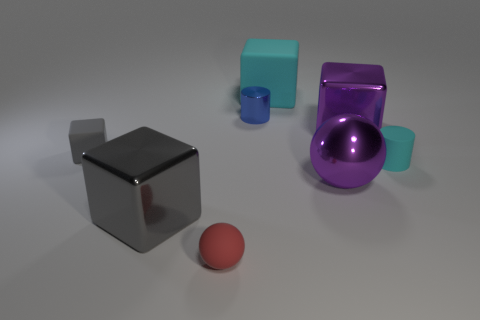Add 1 tiny blue things. How many objects exist? 9 Subtract all cylinders. How many objects are left? 6 Add 2 large purple objects. How many large purple objects are left? 4 Add 1 small yellow things. How many small yellow things exist? 1 Subtract 0 brown cylinders. How many objects are left? 8 Subtract all cylinders. Subtract all tiny shiny objects. How many objects are left? 5 